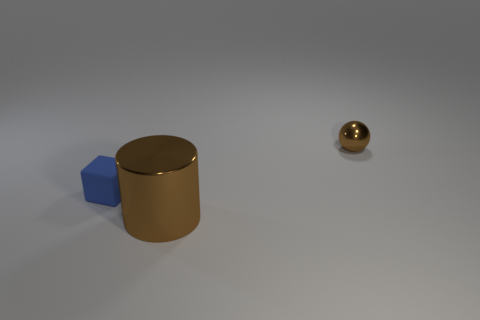Add 1 big cylinders. How many objects exist? 4 Subtract all cubes. How many objects are left? 2 Add 3 small blue matte blocks. How many small blue matte blocks are left? 4 Add 2 tiny purple rubber balls. How many tiny purple rubber balls exist? 2 Subtract 1 brown cylinders. How many objects are left? 2 Subtract all metal things. Subtract all tiny matte things. How many objects are left? 0 